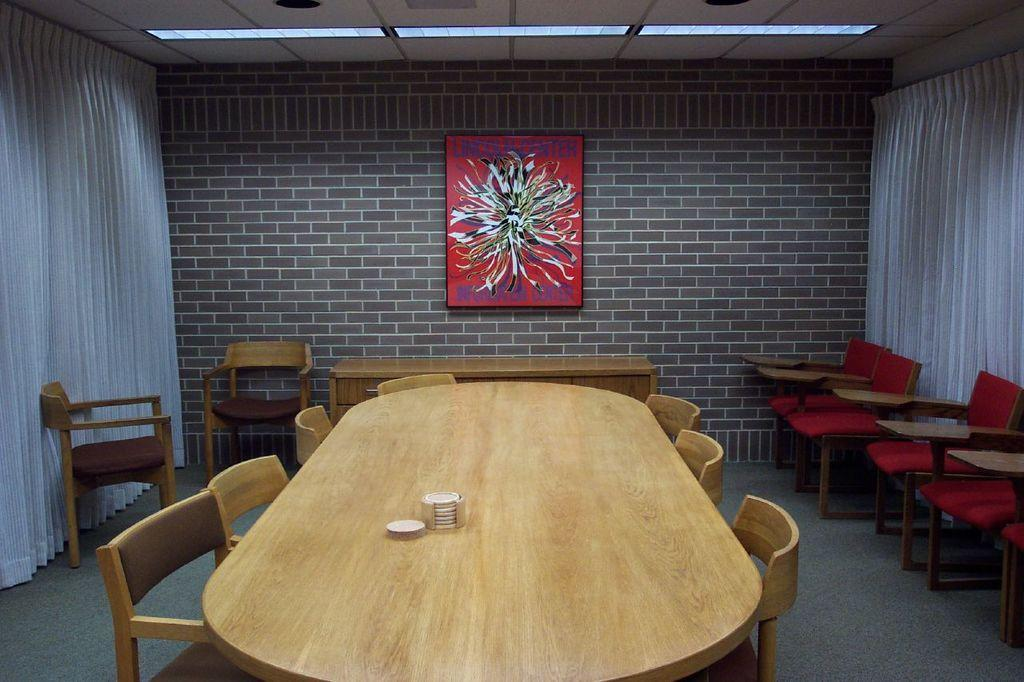What type of furniture is in the center of the image? There is a dining table in the image. What is used to sit at the dining table? Chairs are present around the dining table. What can be seen on a wall in the image? There is a frame on a wall in the image. What type of field is visible through the window in the image? There is no window or field present in the image; it only features a dining table, chairs, and a frame on a wall. 